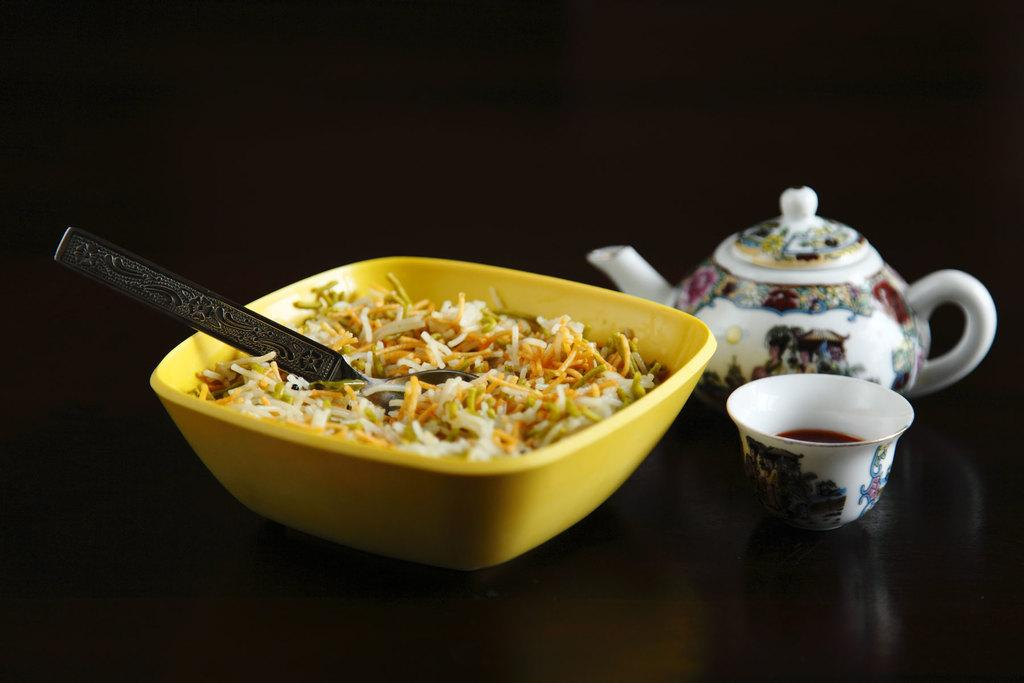What is in the bowl that is visible in the image? There is a bowl with food in the image. What utensil is present in the image? There is a spoon in the image. What other kitchen item can be seen in the image? There is a kettle in the image. What might be used for drinking in the image? There is a cup in the image. What is the color of the surface beneath the items? The surface beneath the items is black. What type of bomb is visible in the image? There is no bomb present in the image. What season is depicted in the image? The image does not depict a specific season, so it cannot be determined from the image. 